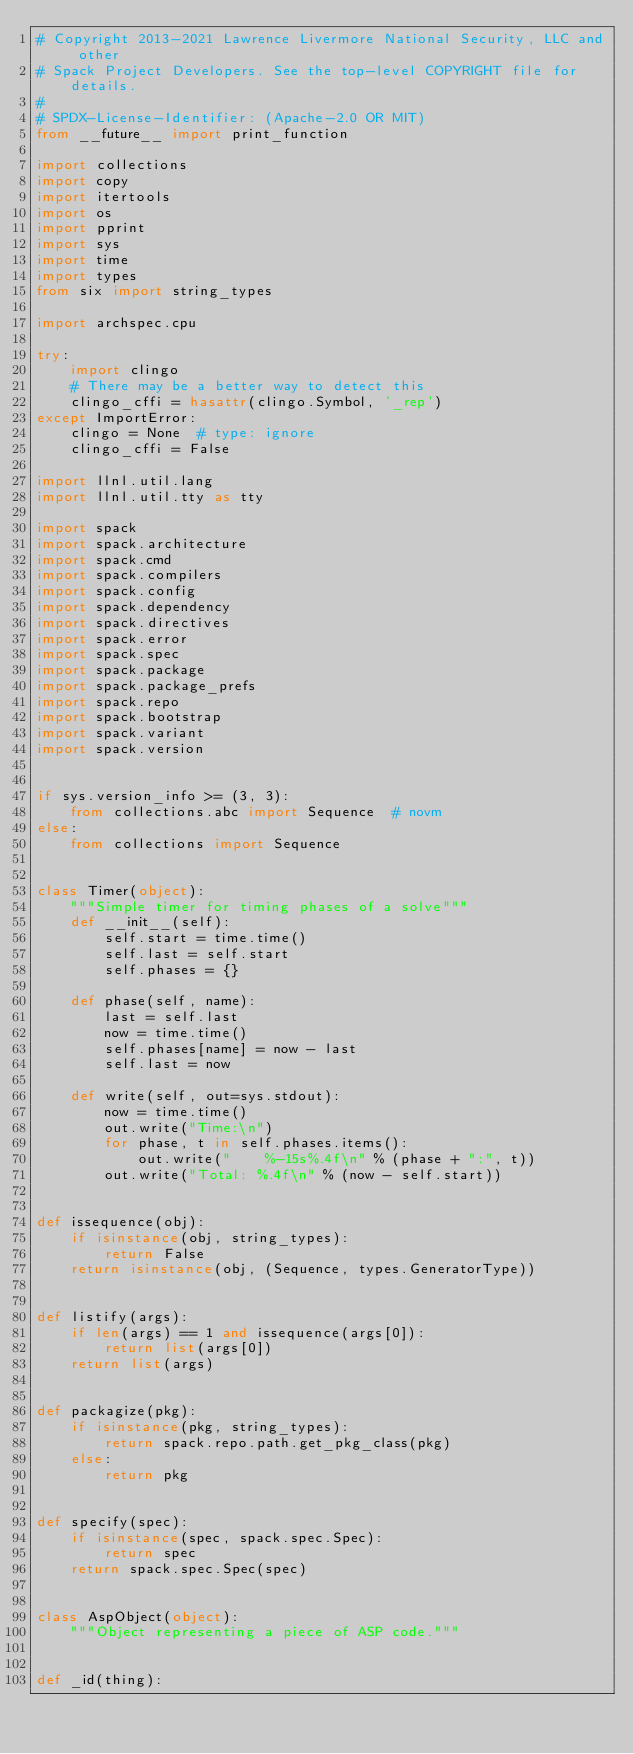<code> <loc_0><loc_0><loc_500><loc_500><_Python_># Copyright 2013-2021 Lawrence Livermore National Security, LLC and other
# Spack Project Developers. See the top-level COPYRIGHT file for details.
#
# SPDX-License-Identifier: (Apache-2.0 OR MIT)
from __future__ import print_function

import collections
import copy
import itertools
import os
import pprint
import sys
import time
import types
from six import string_types

import archspec.cpu

try:
    import clingo
    # There may be a better way to detect this
    clingo_cffi = hasattr(clingo.Symbol, '_rep')
except ImportError:
    clingo = None  # type: ignore
    clingo_cffi = False

import llnl.util.lang
import llnl.util.tty as tty

import spack
import spack.architecture
import spack.cmd
import spack.compilers
import spack.config
import spack.dependency
import spack.directives
import spack.error
import spack.spec
import spack.package
import spack.package_prefs
import spack.repo
import spack.bootstrap
import spack.variant
import spack.version


if sys.version_info >= (3, 3):
    from collections.abc import Sequence  # novm
else:
    from collections import Sequence


class Timer(object):
    """Simple timer for timing phases of a solve"""
    def __init__(self):
        self.start = time.time()
        self.last = self.start
        self.phases = {}

    def phase(self, name):
        last = self.last
        now = time.time()
        self.phases[name] = now - last
        self.last = now

    def write(self, out=sys.stdout):
        now = time.time()
        out.write("Time:\n")
        for phase, t in self.phases.items():
            out.write("    %-15s%.4f\n" % (phase + ":", t))
        out.write("Total: %.4f\n" % (now - self.start))


def issequence(obj):
    if isinstance(obj, string_types):
        return False
    return isinstance(obj, (Sequence, types.GeneratorType))


def listify(args):
    if len(args) == 1 and issequence(args[0]):
        return list(args[0])
    return list(args)


def packagize(pkg):
    if isinstance(pkg, string_types):
        return spack.repo.path.get_pkg_class(pkg)
    else:
        return pkg


def specify(spec):
    if isinstance(spec, spack.spec.Spec):
        return spec
    return spack.spec.Spec(spec)


class AspObject(object):
    """Object representing a piece of ASP code."""


def _id(thing):</code> 